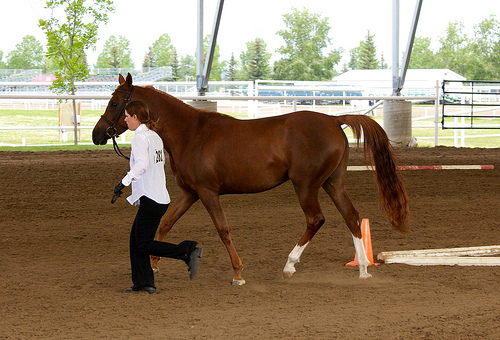<image>
Is there a man under the horse? No. The man is not positioned under the horse. The vertical relationship between these objects is different. Where is the horse in relation to the man? Is it behind the man? Yes. From this viewpoint, the horse is positioned behind the man, with the man partially or fully occluding the horse. Is the horse behind the fence? No. The horse is not behind the fence. From this viewpoint, the horse appears to be positioned elsewhere in the scene. 